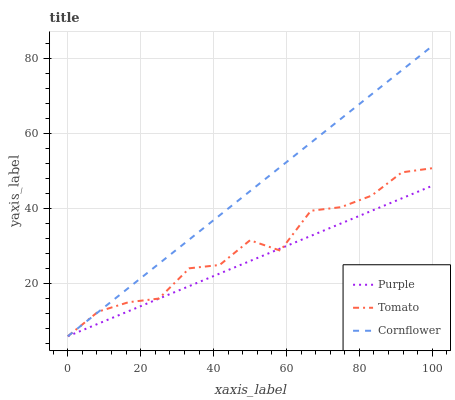Does Tomato have the minimum area under the curve?
Answer yes or no. No. Does Tomato have the maximum area under the curve?
Answer yes or no. No. Is Tomato the smoothest?
Answer yes or no. No. Is Cornflower the roughest?
Answer yes or no. No. Does Tomato have the highest value?
Answer yes or no. No. 